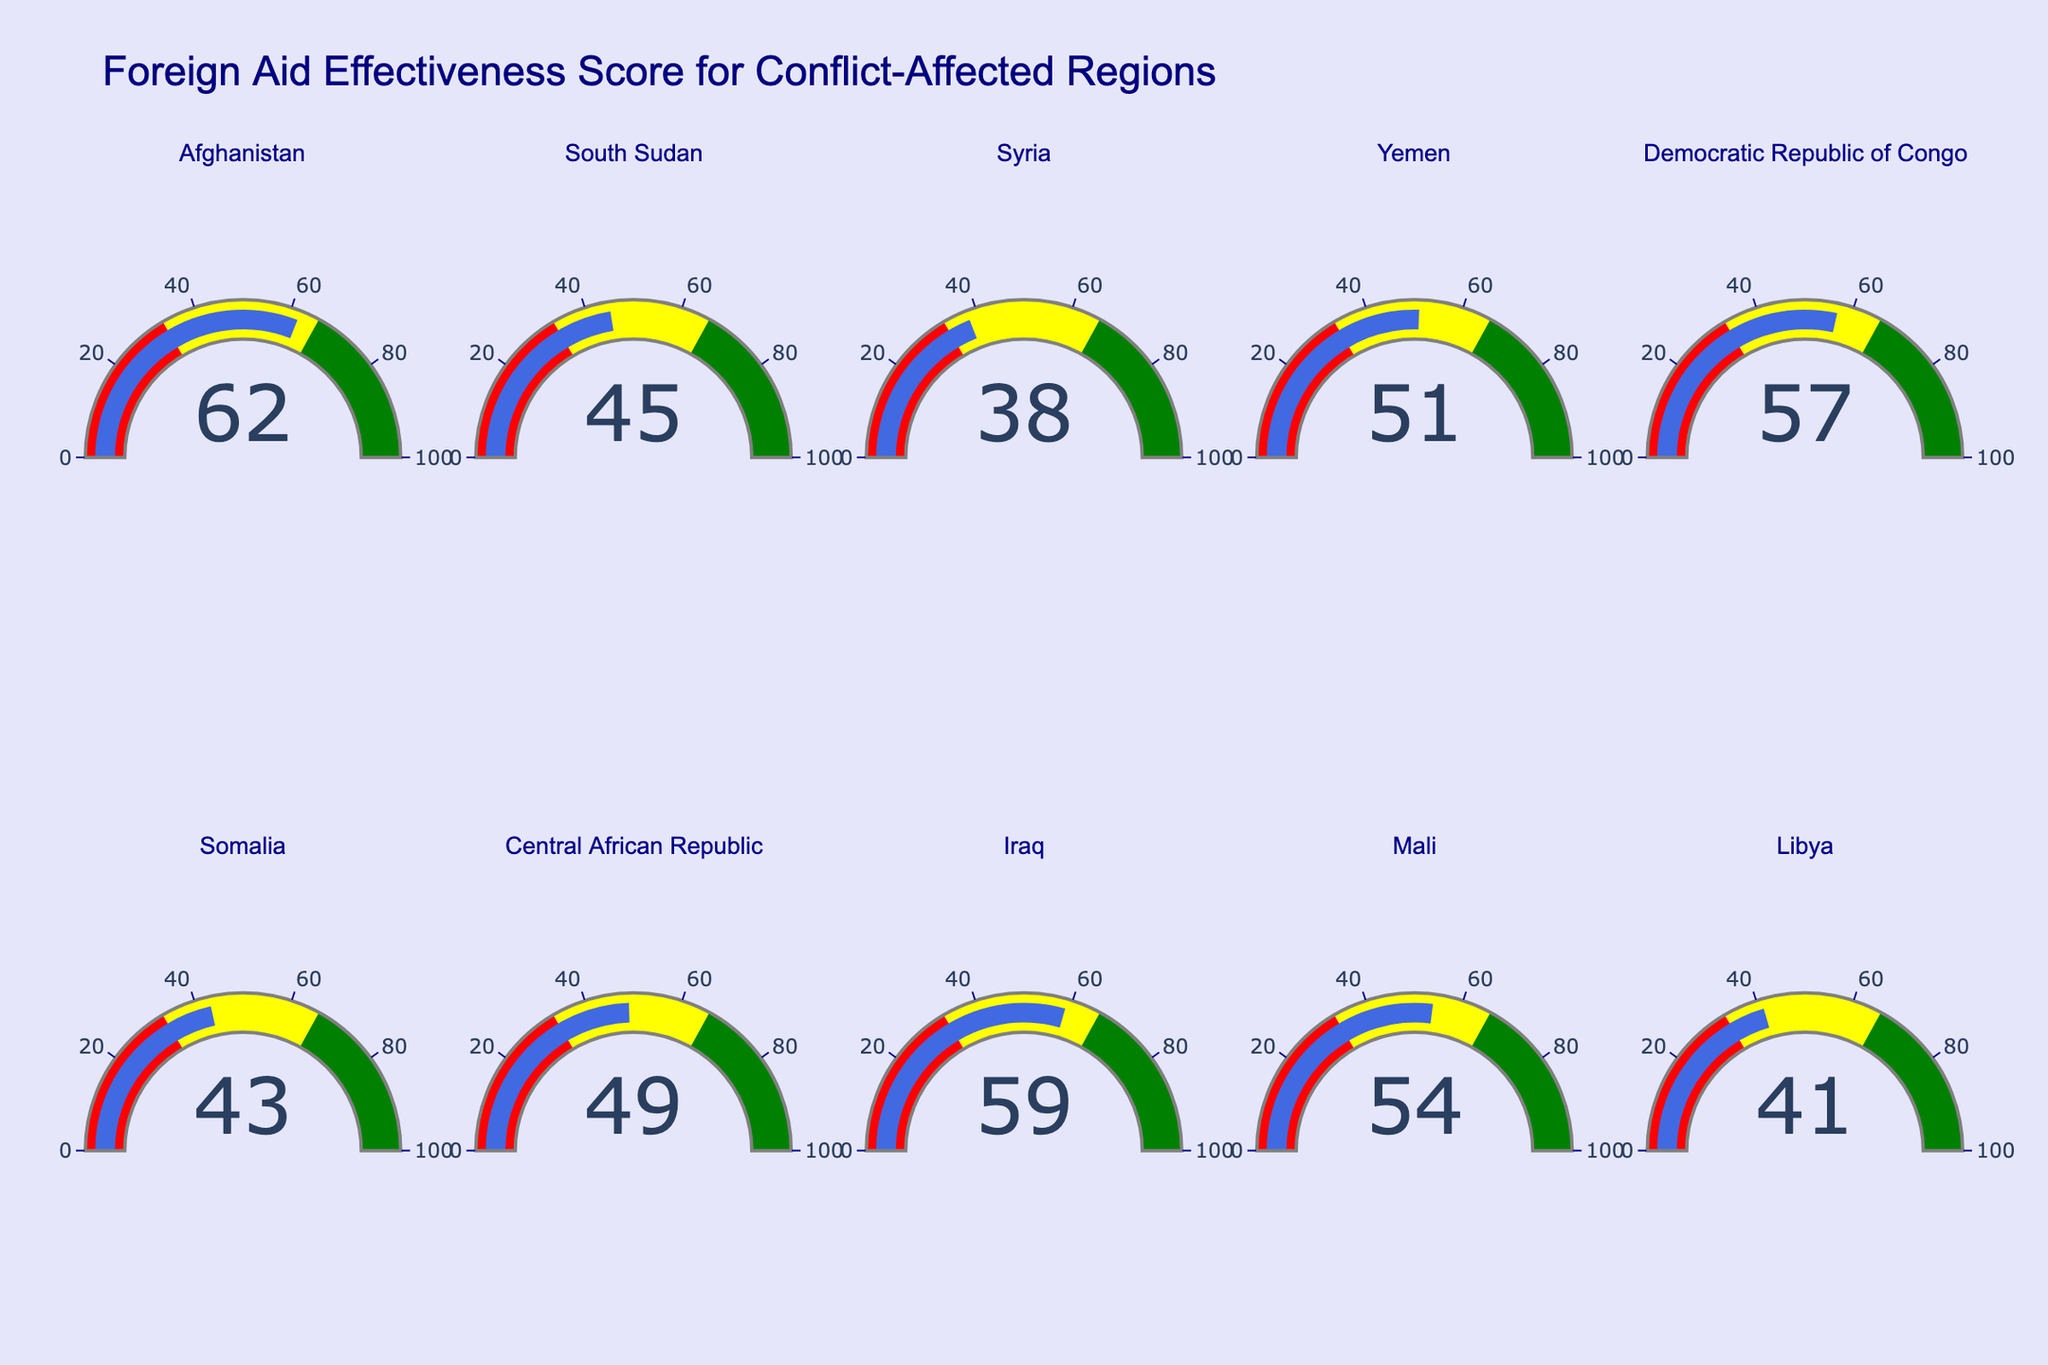What's the highest Aid Effectiveness Score shown in the figure? Identify the highest number displayed on the gauge charts. The highest value among the listed regions (Afghanistan, South Sudan, Syria, etc.) is visually apparent at 62 for Afghanistan.
Answer: 62 Which region has the lowest Aid Effectiveness Score? Look through all the gauge indicators in the figure. The lowest value is 38, which belongs to Syria.
Answer: Syria What is the difference in Aid Effectiveness Scores between Afghanistan and Syria? Afghanistan's score is 62, and Syria's score is 38. Subtract 38 from 62 to get the difference: 62 - 38 = 24.
Answer: 24 Which regions have Aid Effectiveness Scores in the yellow range? The yellow range represents scores from 33 to 66. The regions falling into this category are Afghanistan (62), South Sudan (45), Yemen (51), Democratic Republic of Congo (57), Somalia (43), Central African Republic (49), Iraq (59), and Mali (54).
Answer: Afghanistan, South Sudan, Yemen, Democratic Republic of Congo, Somalia, Central African Republic, Iraq, Mali Are there any regions with Aid Effectiveness Scores in the green range? The green range on the gauge charts represents scores from 66 to 100. Scan through the chart; none of the regions have a score in this range.
Answer: No What is the median Aid Effectiveness Score of all the regions? Arrange the scores in ascending order: 38, 41, 43, 45, 49, 51, 54, 57, 59, 62. Since there are 10 regions, the median value is the average of the 5th and 6th scores (49 and 51). The median is (49 + 51) / 2 = 50.
Answer: 50 Among Iraq, Libya, and Mali, which region has the highest Aid Effectiveness Score? Review the scores for Iraq (59), Libya (41), and Mali (54). Iraq has the highest score at 59.
Answer: Iraq How many regions have Aid Effectiveness Scores below 50? Identify the regions with scores below 50: South Sudan (45), Syria (38), Somalia (43), Central African Republic (49), and Libya (41). There are 5 such regions.
Answer: 5 What is the average Aid Effectiveness Score of the regions in the red range? The red range covers scores from 0 to 33. Since none of the regions have scores in this range, the average score is undefined.
Answer: Undefined 